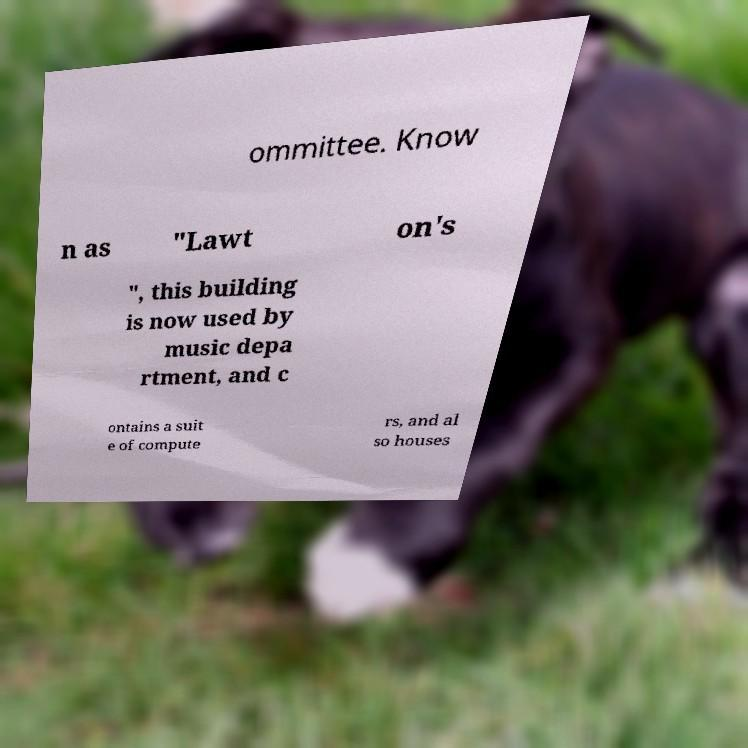For documentation purposes, I need the text within this image transcribed. Could you provide that? ommittee. Know n as "Lawt on's ", this building is now used by music depa rtment, and c ontains a suit e of compute rs, and al so houses 